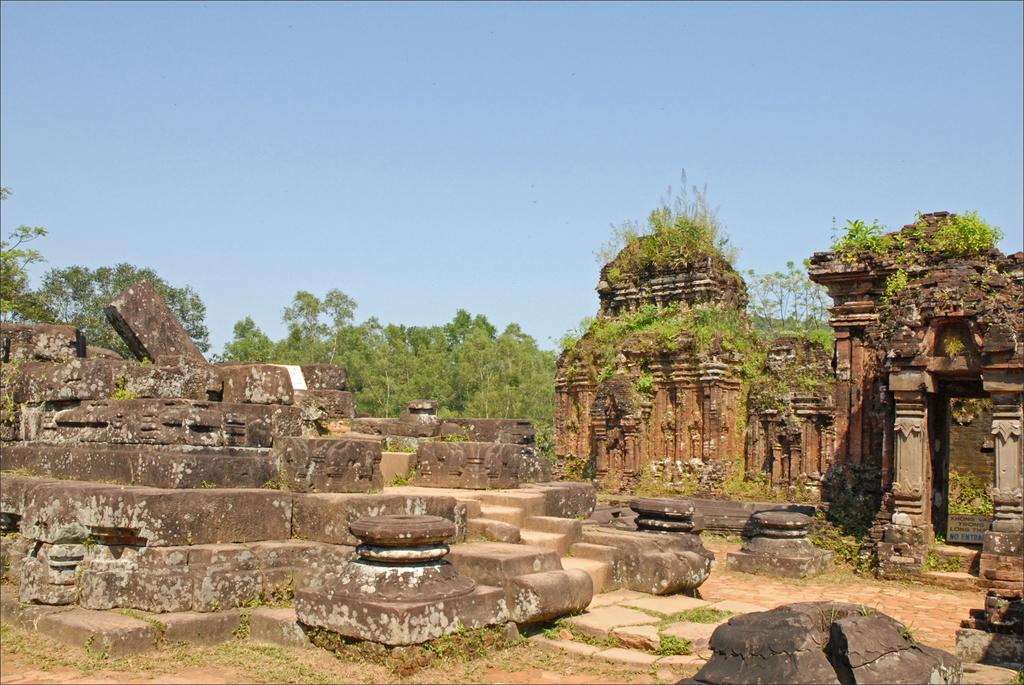What can be seen in the sky in the image? There is sky visible in the image. What type of natural elements are present in the image? There are trees and plants in the image. What type of man-made structures can be seen in the image? There are ruins in the image. What type of surface is visible in the image? There is a floor in the image. Can you see any quicksand in the image? There is no quicksand present in the image. What type of print is visible on the floor in the image? There is no print visible on the floor in the image. 